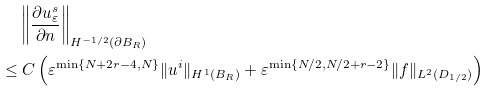<formula> <loc_0><loc_0><loc_500><loc_500>& \left \| \frac { \partial u _ { \varepsilon } ^ { s } } { \partial n } \right \| _ { H ^ { - 1 / 2 } ( \partial B _ { R } ) } \\ \leq & \ C \left ( \varepsilon ^ { \min \{ N + 2 r - 4 , N \} } \| u ^ { i } \| _ { H ^ { 1 } ( B _ { R } ) } + \varepsilon ^ { \min \{ N / 2 , N / 2 + r - 2 \} } \| f \| _ { L ^ { 2 } ( D _ { 1 / 2 } ) } \right )</formula> 